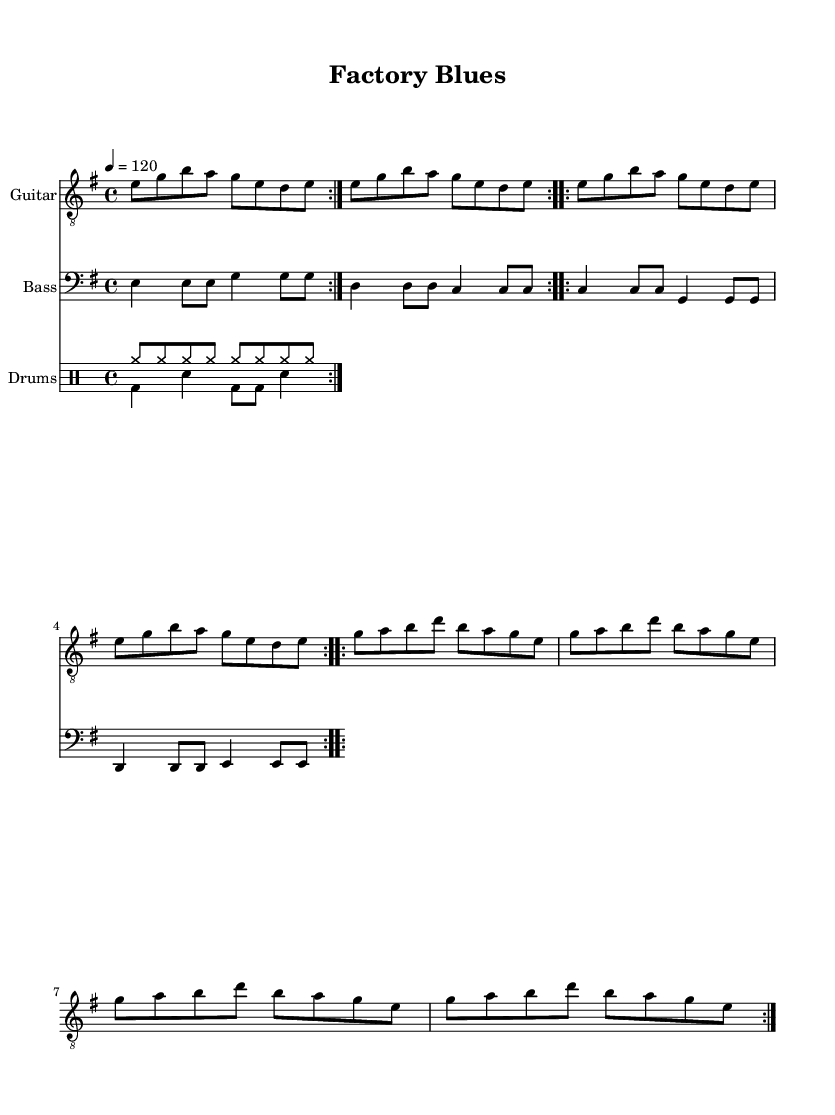What is the key signature of this music? The key signature is E minor, which has one sharp (F#). It can be identified by looking at the key signature symbol at the beginning of the staff, after the clef symbol.
Answer: E minor What is the time signature of this music? The time signature is 4/4, which means there are four beats in each measure, and the quarter note gets one beat. This can be determined by looking for the fraction at the beginning of the music sheet after the key signature.
Answer: 4/4 What is the tempo marking of this music? The tempo marking is 120 beats per minute, shown at the beginning of the score. It indicates the speed of the music. This can be found near the top of the sheet, where it specifies how fast the piece should be played.
Answer: 120 How many measures are there in the guitar part? To find the number of measures, one can count the number of distinct groups of notes in the guitar staff. Each group of notes between vertical lines (bar lines) represents a measure. In this case, there are 16 measures in total.
Answer: 16 What is the rhythmic pattern of the drums in the second section? The rhythmic pattern combines bass drum hits and snares. Specifically, it has four quarter notes followed by an eighth and a quarter note. By analyzing the note values in the drum staff, we can see this repeated pattern.
Answer: bass and snare What are the first two notes of the bass part? The first two notes of the bass part are E and E. These are the pitches that can be found in the first two note positions of the bass staff. Identifying the notes involves looking at the staff and recognizing the position on the lines and spaces.
Answer: E and E What is the overall musical form of this piece? The overall musical form can be identified as a repeated structure. The 'volta' indications in the score show that both the guitar and bass parts repeat sections. Analyzing the layout of repeated sections allows us to conclude the overall form used is AABA.
Answer: AABA 